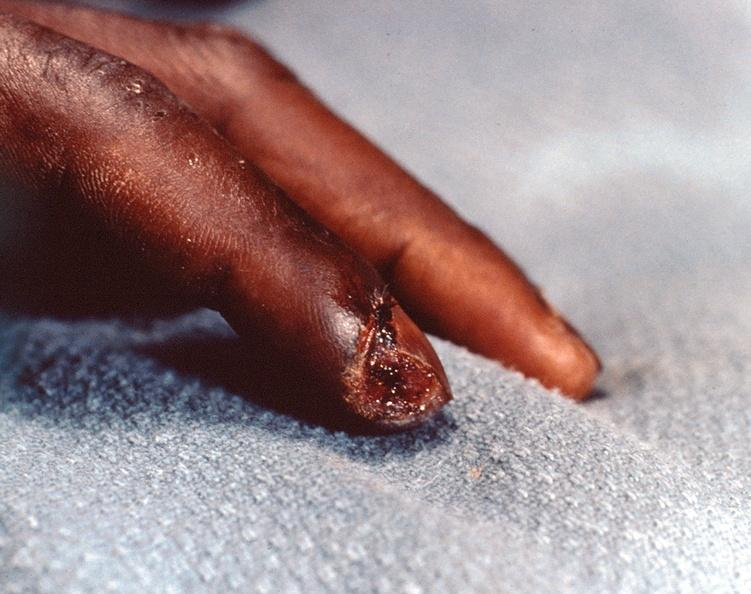re cells present?
Answer the question using a single word or phrase. No 